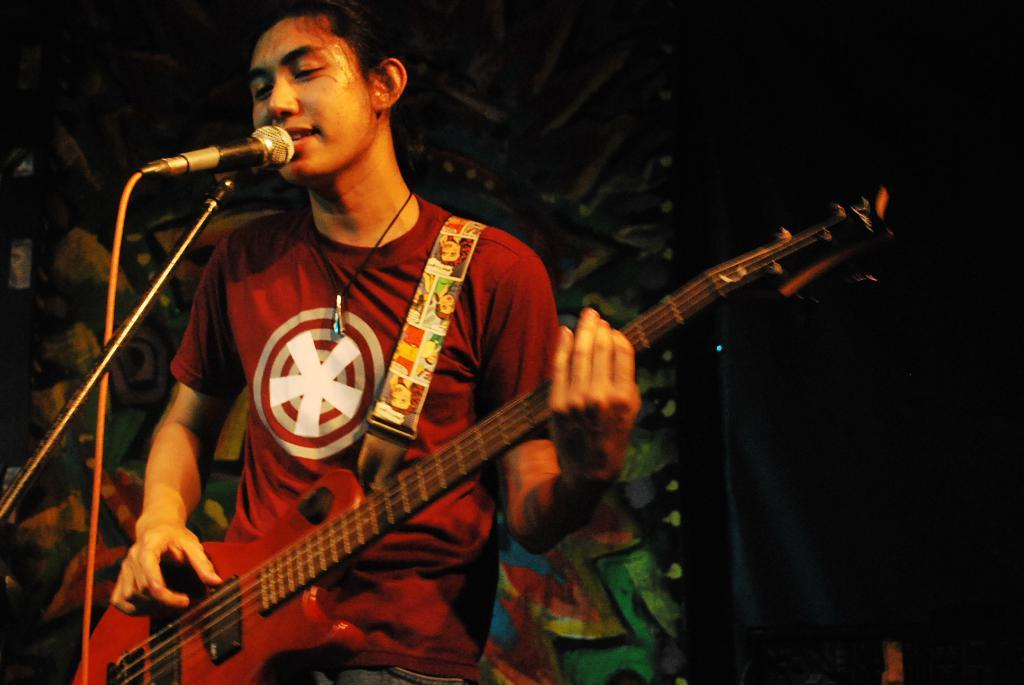What is the man in the image doing? The man is singing a song. What is the man wearing in the image? The man is wearing a red t-shirt. What object is the man holding in the image? The man is holding a guitar. What equipment is in front of the man in the image? There is a microphone with a stand in front of the man. What can be seen on the wall behind the man in the image? There are paintings on the wall behind the man. How does the man balance on the roll in the image? There is no roll present in the image; the man is standing on the ground. What type of cake is being served for the man's birthday in the image? There is no cake or birthday celebration depicted in the image. 